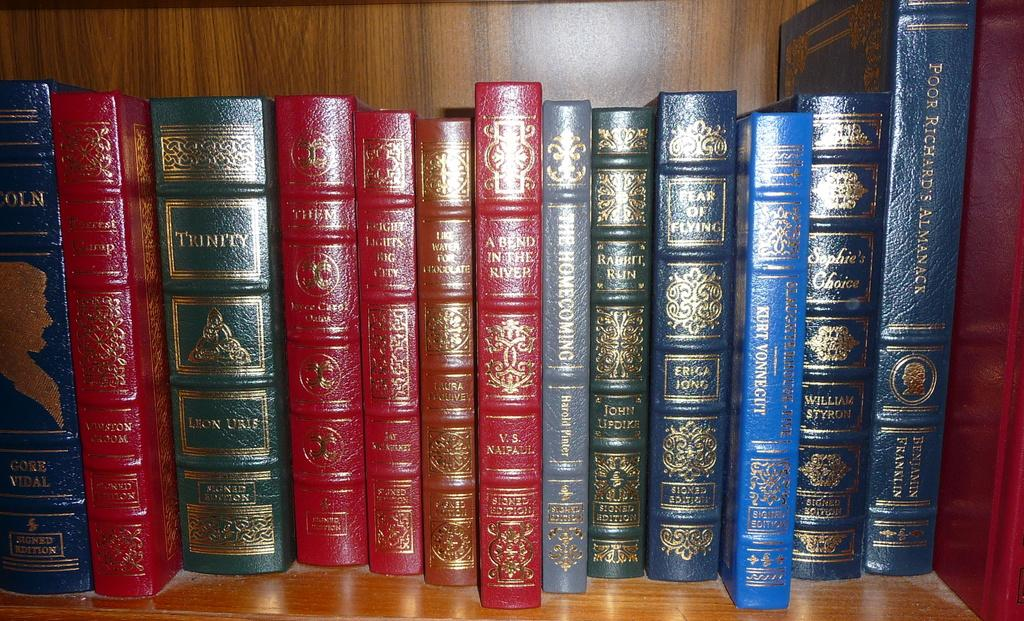What is the main subject of the image? The main subject of the image is many books. Where are the books located in the image? The books are kept on a shelf in the image. What can be observed about the appearance of the books? The books are in different colors. How many trucks are parked next to the bookshelf in the image? There are no trucks present in the image; it only features books on a shelf. 